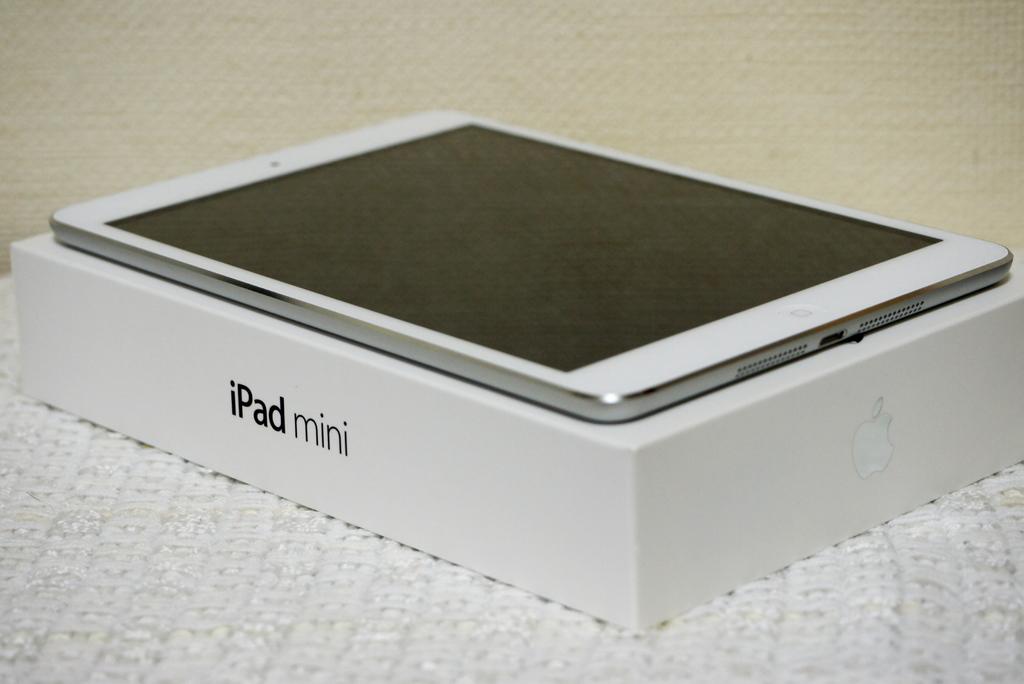What kind of tablet is this?
Offer a terse response. Ipad mini. What brand is the tablet?
Offer a terse response. Ipad. 